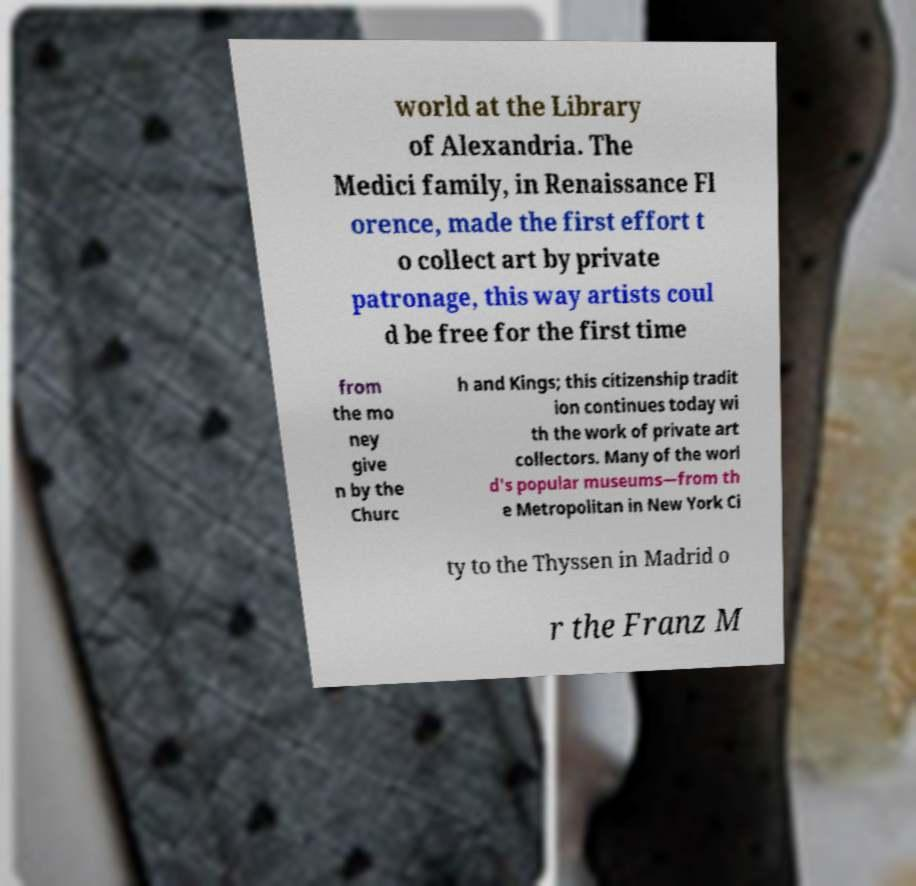There's text embedded in this image that I need extracted. Can you transcribe it verbatim? world at the Library of Alexandria. The Medici family, in Renaissance Fl orence, made the first effort t o collect art by private patronage, this way artists coul d be free for the first time from the mo ney give n by the Churc h and Kings; this citizenship tradit ion continues today wi th the work of private art collectors. Many of the worl d's popular museums—from th e Metropolitan in New York Ci ty to the Thyssen in Madrid o r the Franz M 